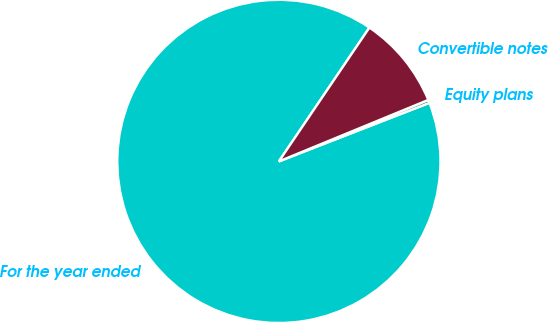Convert chart to OTSL. <chart><loc_0><loc_0><loc_500><loc_500><pie_chart><fcel>For the year ended<fcel>Equity plans<fcel>Convertible notes<nl><fcel>90.37%<fcel>0.31%<fcel>9.32%<nl></chart> 